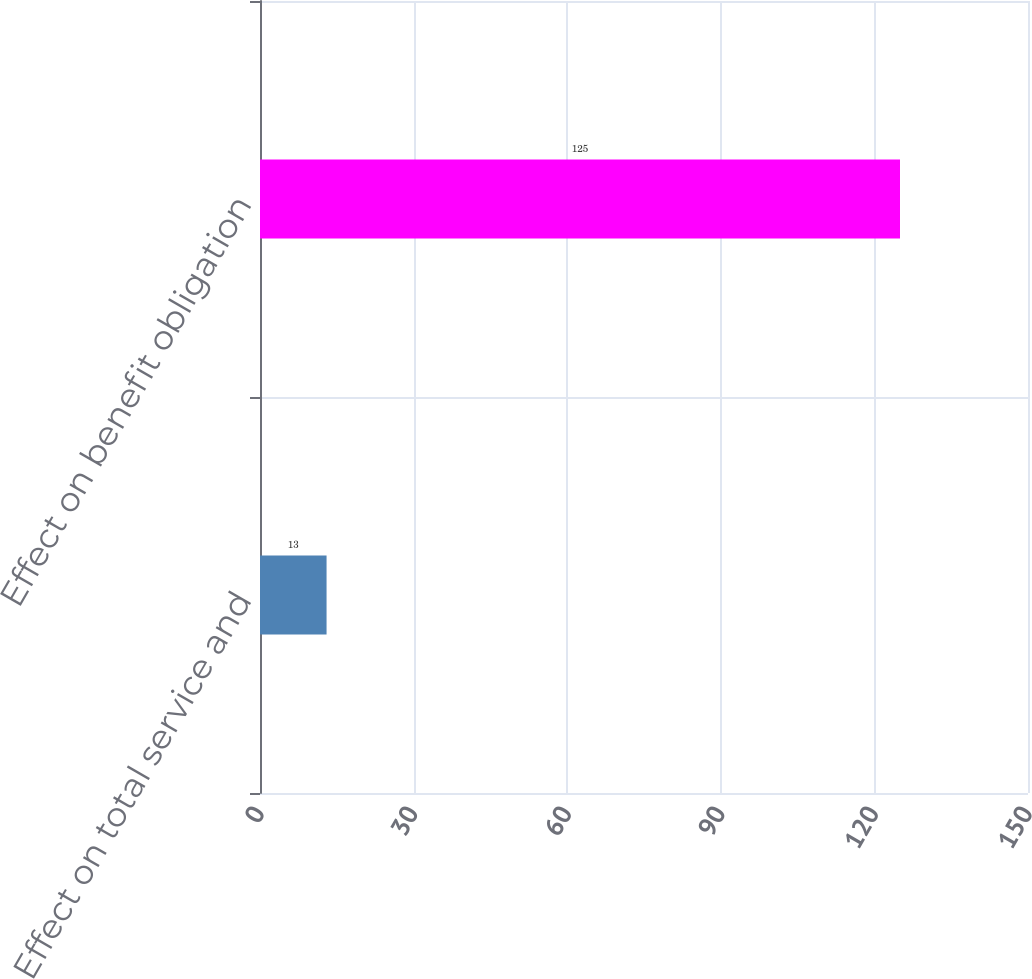Convert chart. <chart><loc_0><loc_0><loc_500><loc_500><bar_chart><fcel>Effect on total service and<fcel>Effect on benefit obligation<nl><fcel>13<fcel>125<nl></chart> 